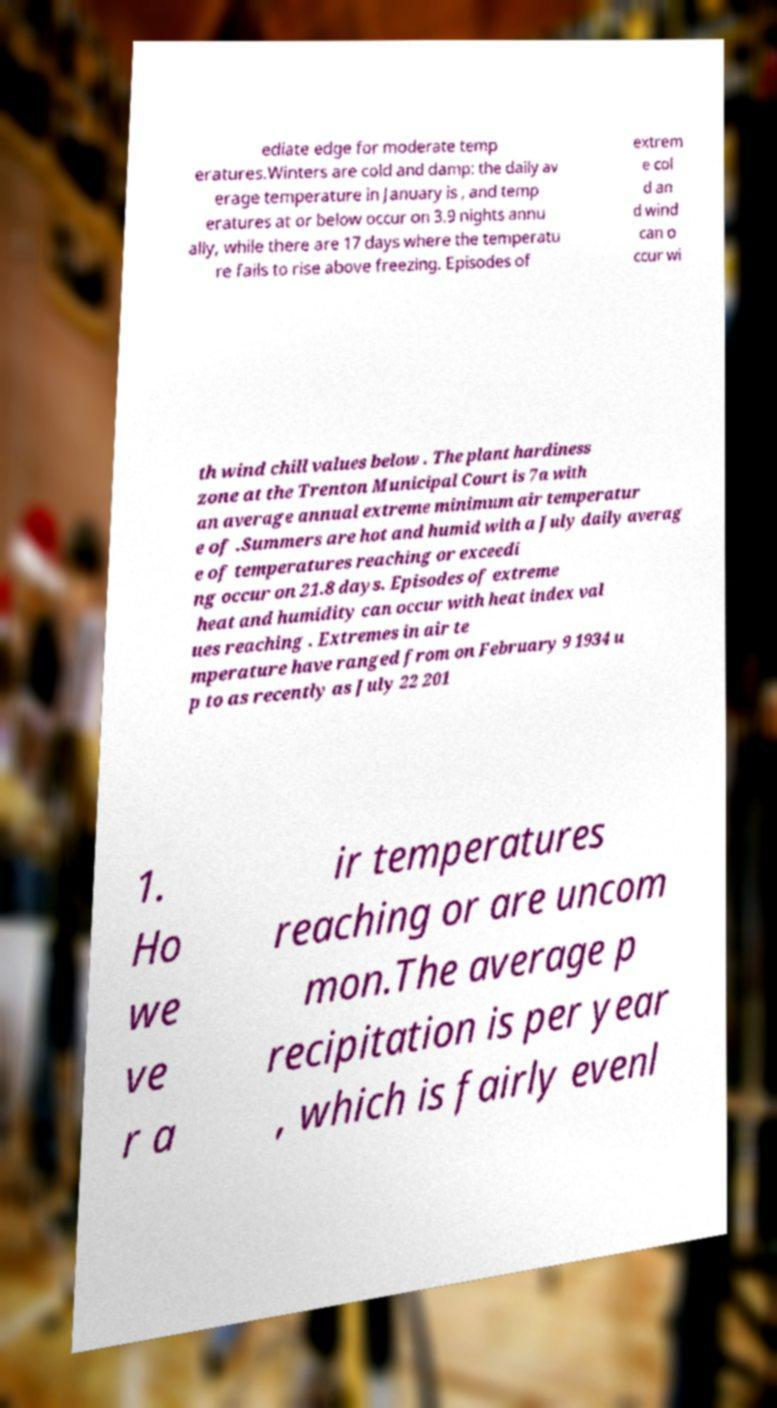Could you assist in decoding the text presented in this image and type it out clearly? ediate edge for moderate temp eratures.Winters are cold and damp: the daily av erage temperature in January is , and temp eratures at or below occur on 3.9 nights annu ally, while there are 17 days where the temperatu re fails to rise above freezing. Episodes of extrem e col d an d wind can o ccur wi th wind chill values below . The plant hardiness zone at the Trenton Municipal Court is 7a with an average annual extreme minimum air temperatur e of .Summers are hot and humid with a July daily averag e of temperatures reaching or exceedi ng occur on 21.8 days. Episodes of extreme heat and humidity can occur with heat index val ues reaching . Extremes in air te mperature have ranged from on February 9 1934 u p to as recently as July 22 201 1. Ho we ve r a ir temperatures reaching or are uncom mon.The average p recipitation is per year , which is fairly evenl 